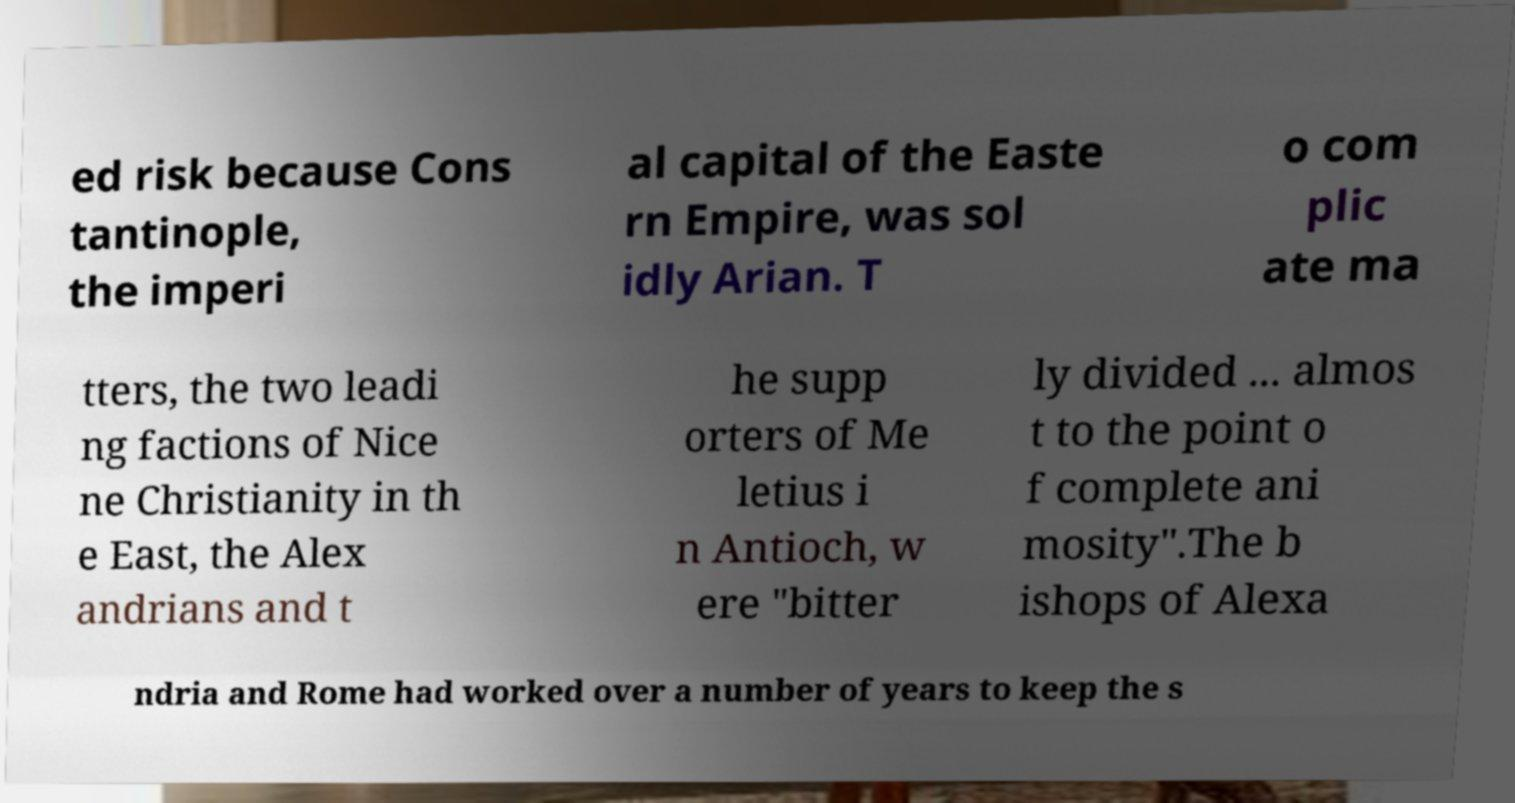I need the written content from this picture converted into text. Can you do that? ed risk because Cons tantinople, the imperi al capital of the Easte rn Empire, was sol idly Arian. T o com plic ate ma tters, the two leadi ng factions of Nice ne Christianity in th e East, the Alex andrians and t he supp orters of Me letius i n Antioch, w ere "bitter ly divided ... almos t to the point o f complete ani mosity".The b ishops of Alexa ndria and Rome had worked over a number of years to keep the s 